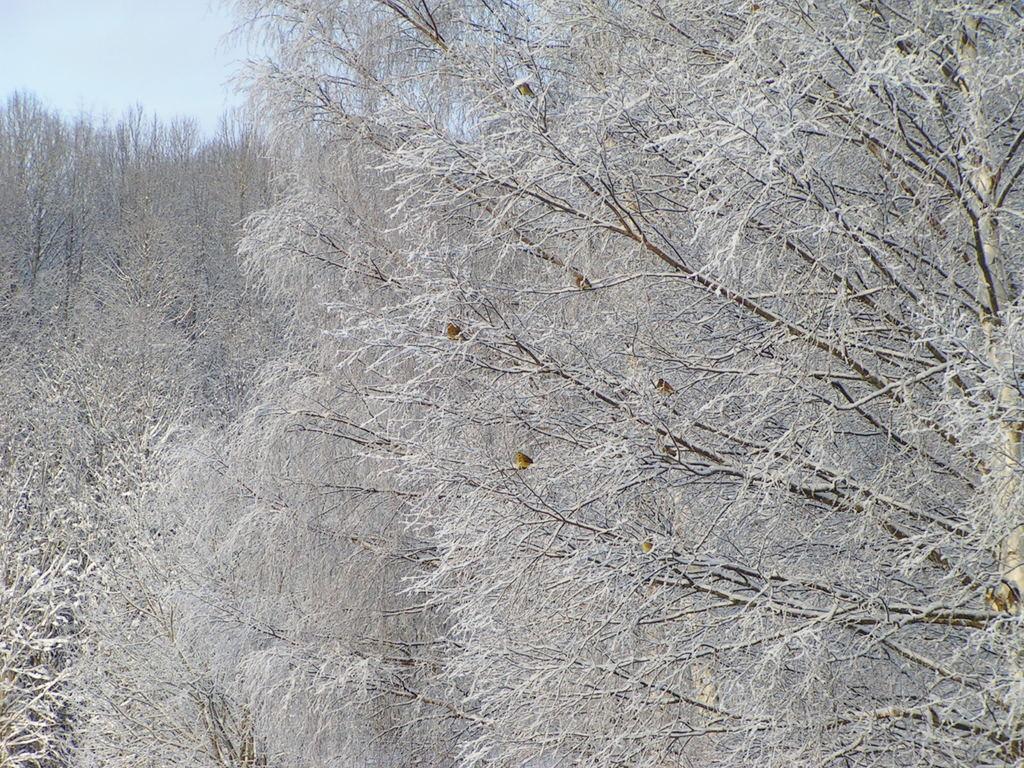Can you describe this image briefly? In this image we can see the trees, on the trees it looks like butterflies. In the background, we can see the sky. 